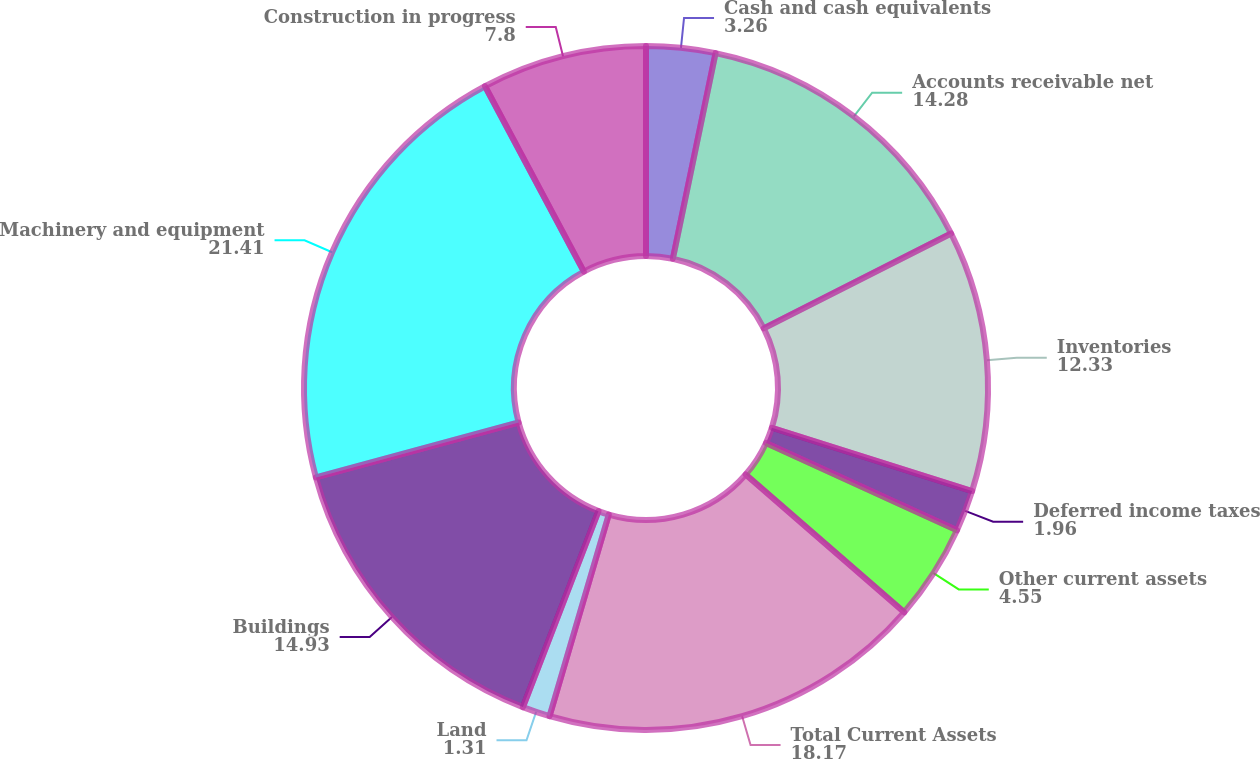Convert chart to OTSL. <chart><loc_0><loc_0><loc_500><loc_500><pie_chart><fcel>Cash and cash equivalents<fcel>Accounts receivable net<fcel>Inventories<fcel>Deferred income taxes<fcel>Other current assets<fcel>Total Current Assets<fcel>Land<fcel>Buildings<fcel>Machinery and equipment<fcel>Construction in progress<nl><fcel>3.26%<fcel>14.28%<fcel>12.33%<fcel>1.96%<fcel>4.55%<fcel>18.17%<fcel>1.31%<fcel>14.93%<fcel>21.41%<fcel>7.8%<nl></chart> 